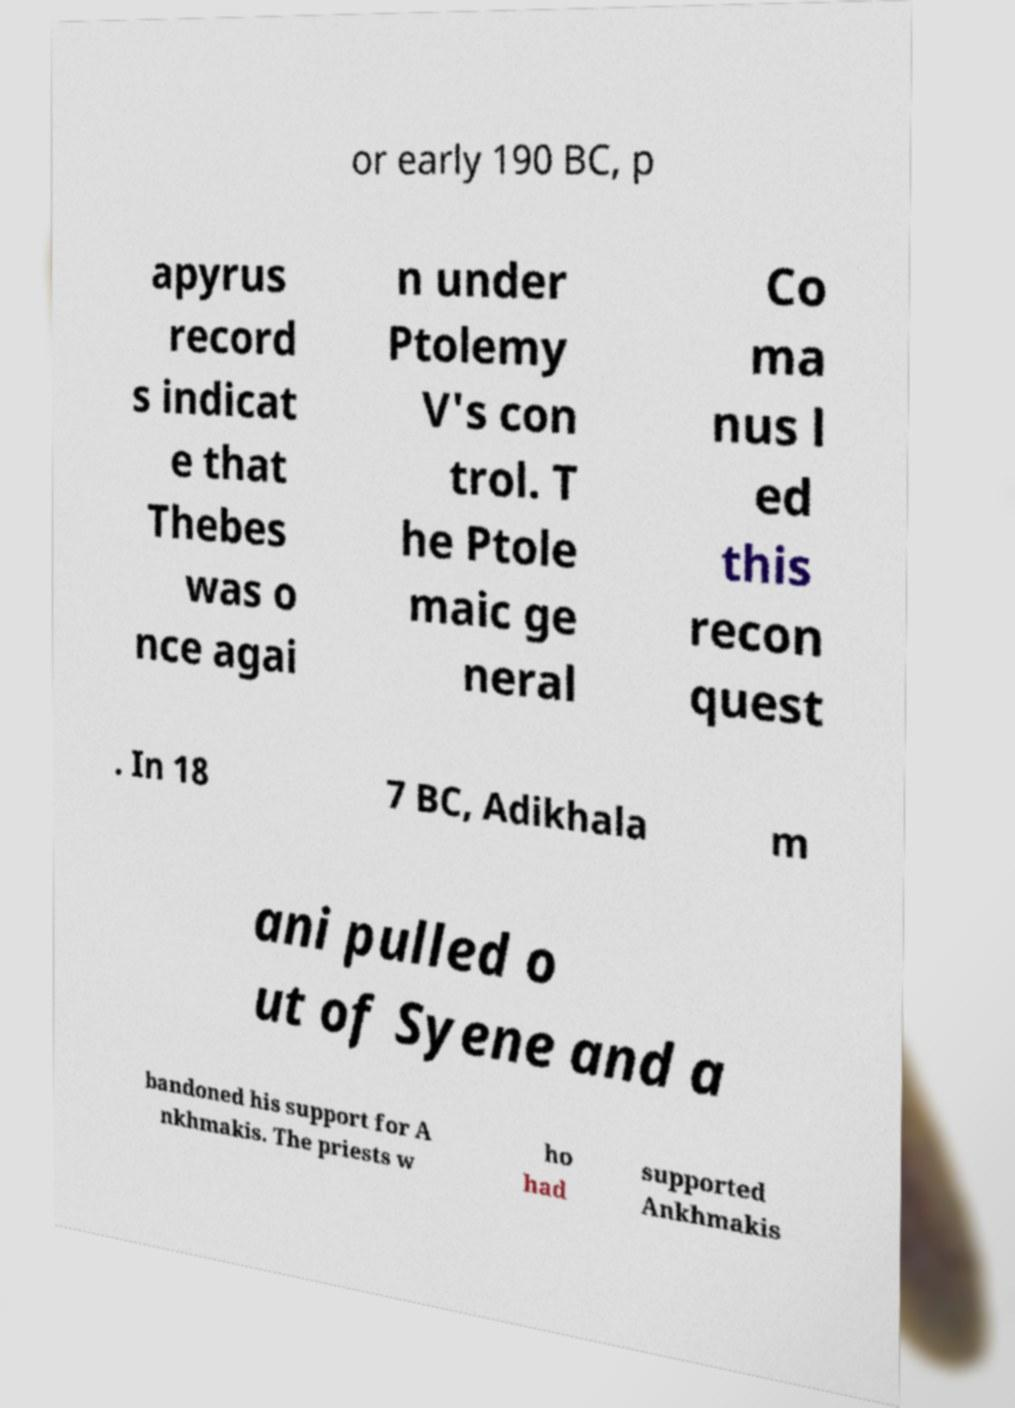There's text embedded in this image that I need extracted. Can you transcribe it verbatim? or early 190 BC, p apyrus record s indicat e that Thebes was o nce agai n under Ptolemy V's con trol. T he Ptole maic ge neral Co ma nus l ed this recon quest . In 18 7 BC, Adikhala m ani pulled o ut of Syene and a bandoned his support for A nkhmakis. The priests w ho had supported Ankhmakis 